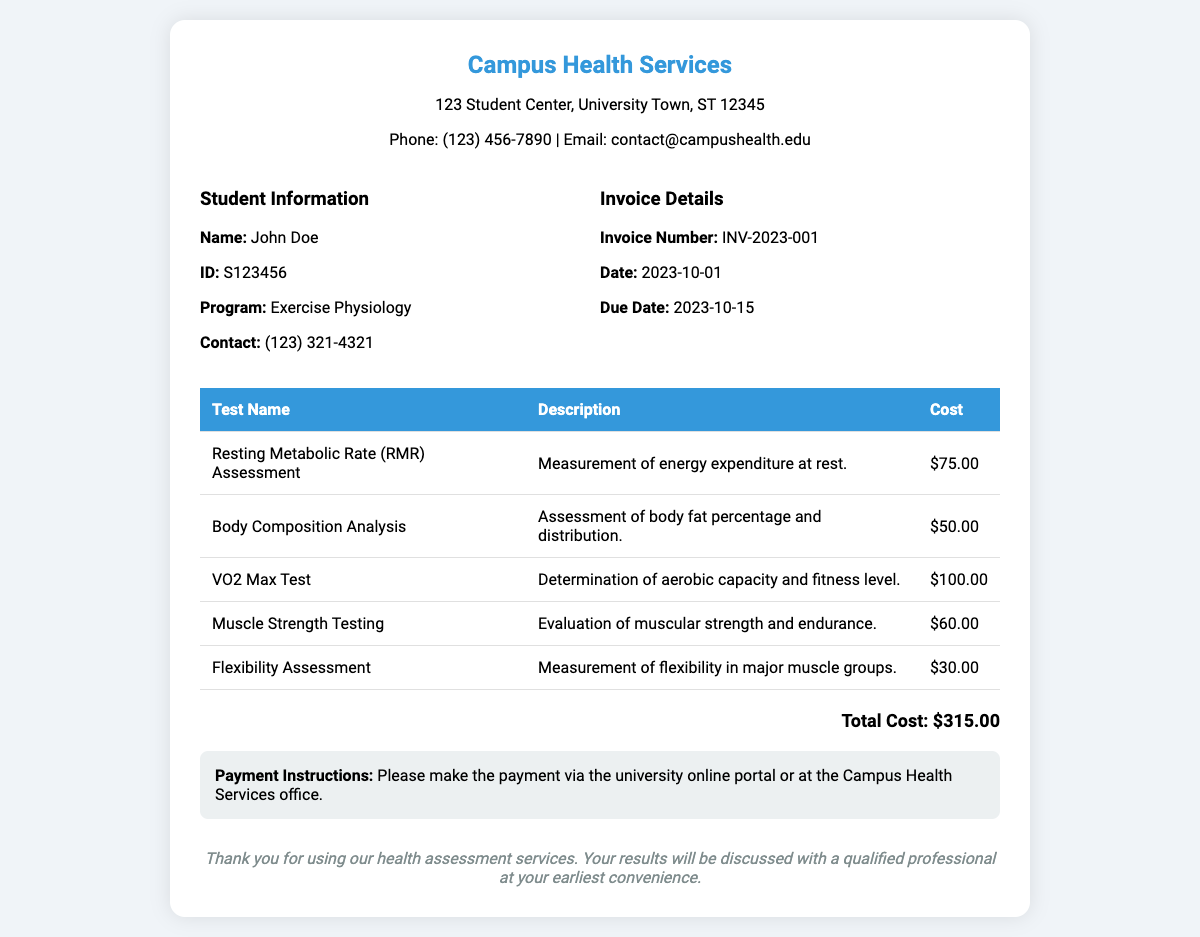What is the student's name? The student's name is listed under the "Student Information" section.
Answer: John Doe What is the invoice number? The invoice number is found in the "Invoice Details" section.
Answer: INV-2023-001 What is the cost of the VO2 Max Test? The cost can be found in the table listing tests performed.
Answer: $100.00 When is the due date for the invoice? The due date is stated in the "Invoice Details" section.
Answer: 2023-10-15 What total amount is due for the services rendered? The total cost is summarized at the bottom of the invoice.
Answer: $315.00 How many tests are listed on the invoice? By counting the rows in the test table, you can determine the number of tests.
Answer: 5 What service is described as "Evaluation of muscular strength and endurance"? The description is associated with a specific test listed in the table.
Answer: Muscle Strength Testing What is the contact number for Campus Health Services? The contact number is provided at the top of the invoice document.
Answer: (123) 456-7890 What is the payment instruction presented in the document? The payment instructions are described in a dedicated section of the invoice.
Answer: Please make the payment via the university online portal or at the Campus Health Services office 